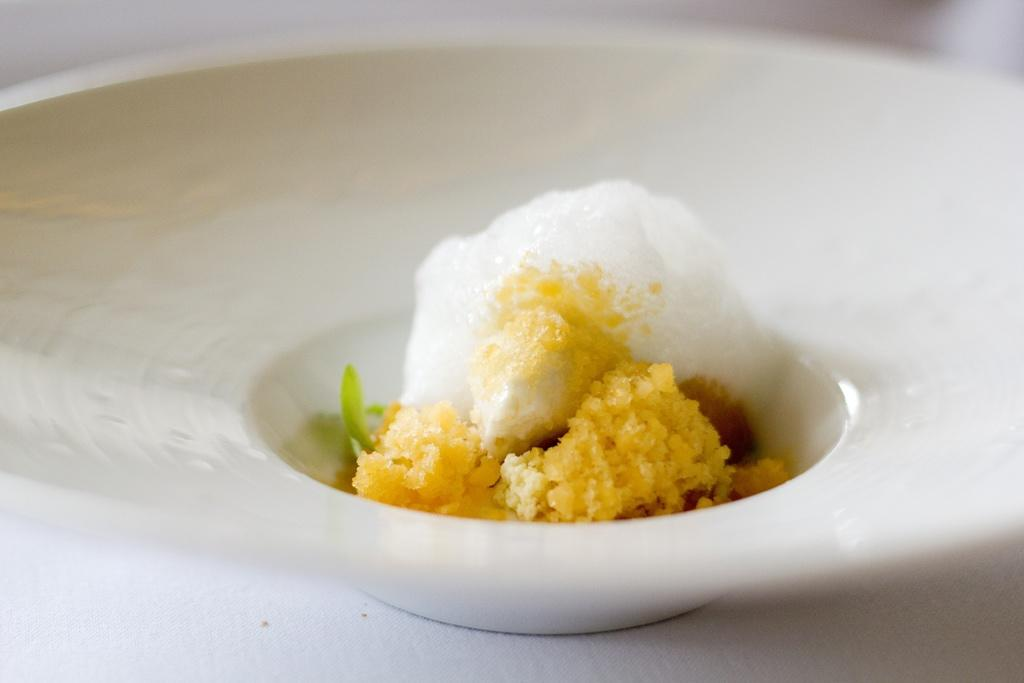What is in the bowl that is visible in the image? The bowl contains food items. Where might the bowl be placed in the image? The bowl may be placed on a table. What type of setting is the image likely taken in? The image is likely taken in a room. What type of soda is being poured into the bowl in the image? There is no soda present in the image; the bowl contains food items. 